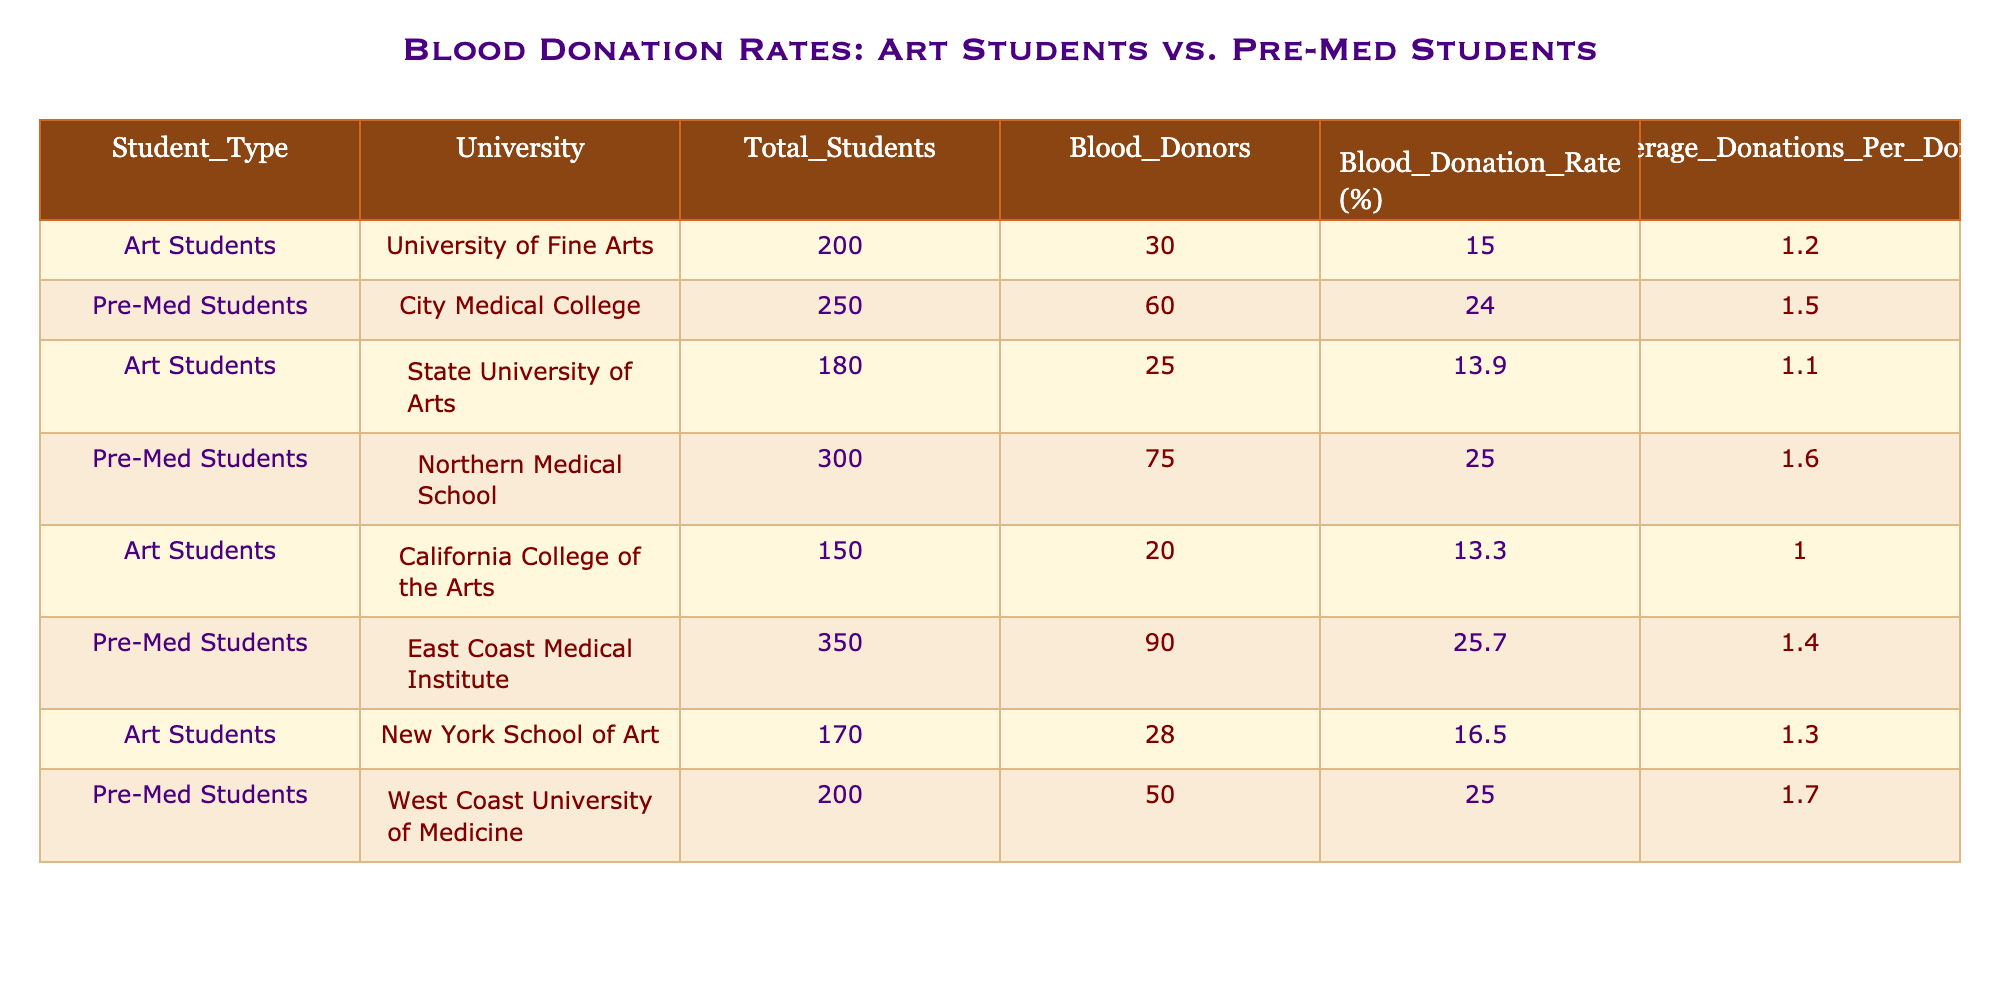What is the blood donation rate for Pre-Med students at City Medical College? The table lists the blood donation rate for Pre-Med students at City Medical College as 24%.
Answer: 24% How many total students are enrolled in Art Students at the California College of the Arts? According to the table, the total number of students enrolled in Art Students at California College of the Arts is 150.
Answer: 150 What is the average number of donations per donor for Pre-Med students at Northern Medical School? The average number of donations per donor for Pre-Med students at Northern Medical School is given as 1.6 in the table.
Answer: 1.6 Which group has a higher average blood donation rate, Art Students or Pre-Med Students? To compare, we calculate the average blood donation rate for both groups. For Art Students: (15 + 13.9 + 13.3 + 16.5) / 4 = 14.675%. For Pre-Med Students: (24 + 25 + 25.7 + 25) / 4 = 24.175%. Since 24.175% is greater than 14.675%, Pre-Med Students have a higher average blood donation rate.
Answer: Pre-Med Students Is it true that the total number of blood donors among Art Students exceeds 100? To evaluate this, we sum the blood donors from all Art Student entries: 30 + 25 + 20 + 28 = 103. Since 103 is more than 100, the statement is true.
Answer: Yes What is the difference in the average donations per donor between Art Students at University of Fine Arts and Pre-Med Students at East Coast Medical Institute? The average donations per donor for Art Students at University of Fine Arts is 1.2 and for Pre-Med Students at East Coast Medical Institute is 1.4. The difference is 1.4 - 1.2 = 0.2. Therefore, Pre-Med Students donate on average 0.2 more donations per donor than Art Students at University of Fine Arts.
Answer: 0.2 How many blood donors were there at the State University of Arts among Art Students? The table indicates that there were 25 blood donors at the State University of Arts among Art Students.
Answer: 25 What is the total number of blood donors for all Pre-Med Students combined? To find the total number of blood donors for all Pre-Med Students, we sum the blood donors: 60 + 75 + 90 + 50 = 275. Therefore, the total number of blood donors for all Pre-Med Students combined is 275.
Answer: 275 